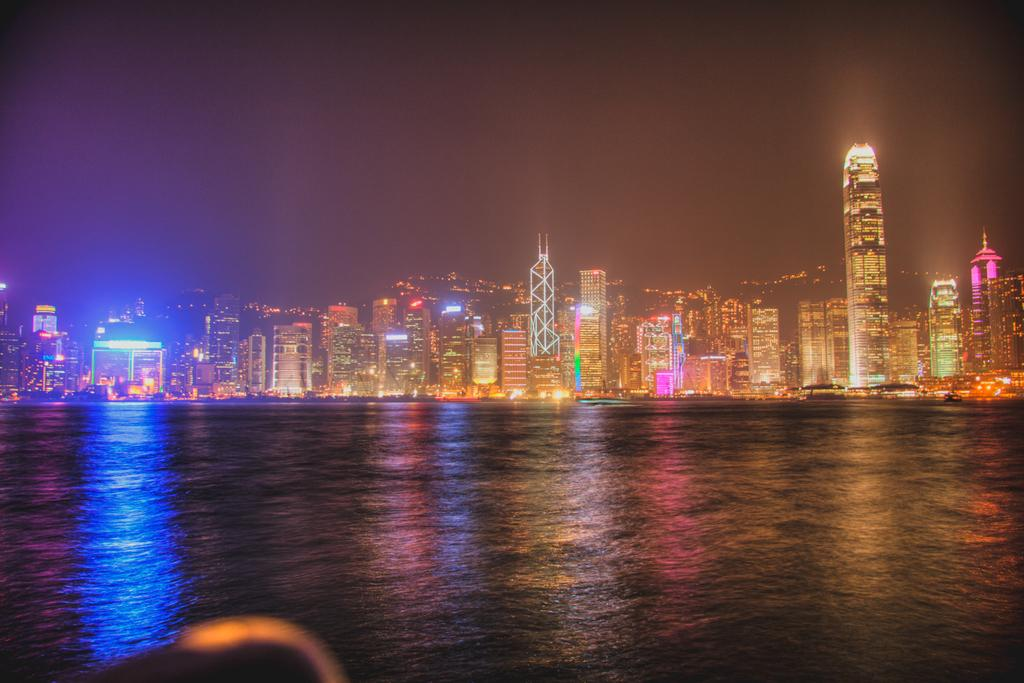What is the primary element in the image? There is water in the image. What can be seen in the background of the image? There are buildings with lights in the background. What is visible at the top of the image? The sky is visible at the top of the image. What type of arch can be seen in the image? There is no arch present in the image. How many marks are visible on the water in the image? There are no marks visible on the water in the image. 